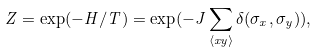<formula> <loc_0><loc_0><loc_500><loc_500>Z = \exp ( - H / T ) = \exp ( - J \sum _ { \langle x y \rangle } \delta ( \sigma _ { x } , \sigma _ { y } ) ) ,</formula> 